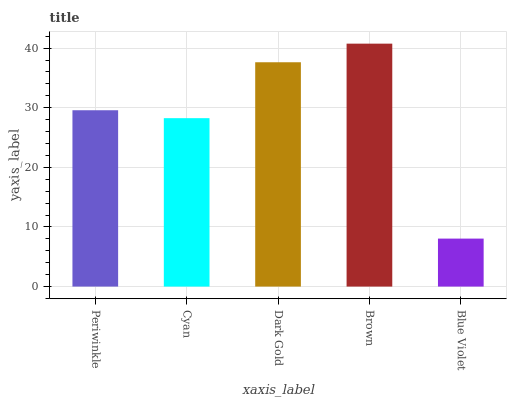Is Blue Violet the minimum?
Answer yes or no. Yes. Is Brown the maximum?
Answer yes or no. Yes. Is Cyan the minimum?
Answer yes or no. No. Is Cyan the maximum?
Answer yes or no. No. Is Periwinkle greater than Cyan?
Answer yes or no. Yes. Is Cyan less than Periwinkle?
Answer yes or no. Yes. Is Cyan greater than Periwinkle?
Answer yes or no. No. Is Periwinkle less than Cyan?
Answer yes or no. No. Is Periwinkle the high median?
Answer yes or no. Yes. Is Periwinkle the low median?
Answer yes or no. Yes. Is Brown the high median?
Answer yes or no. No. Is Cyan the low median?
Answer yes or no. No. 